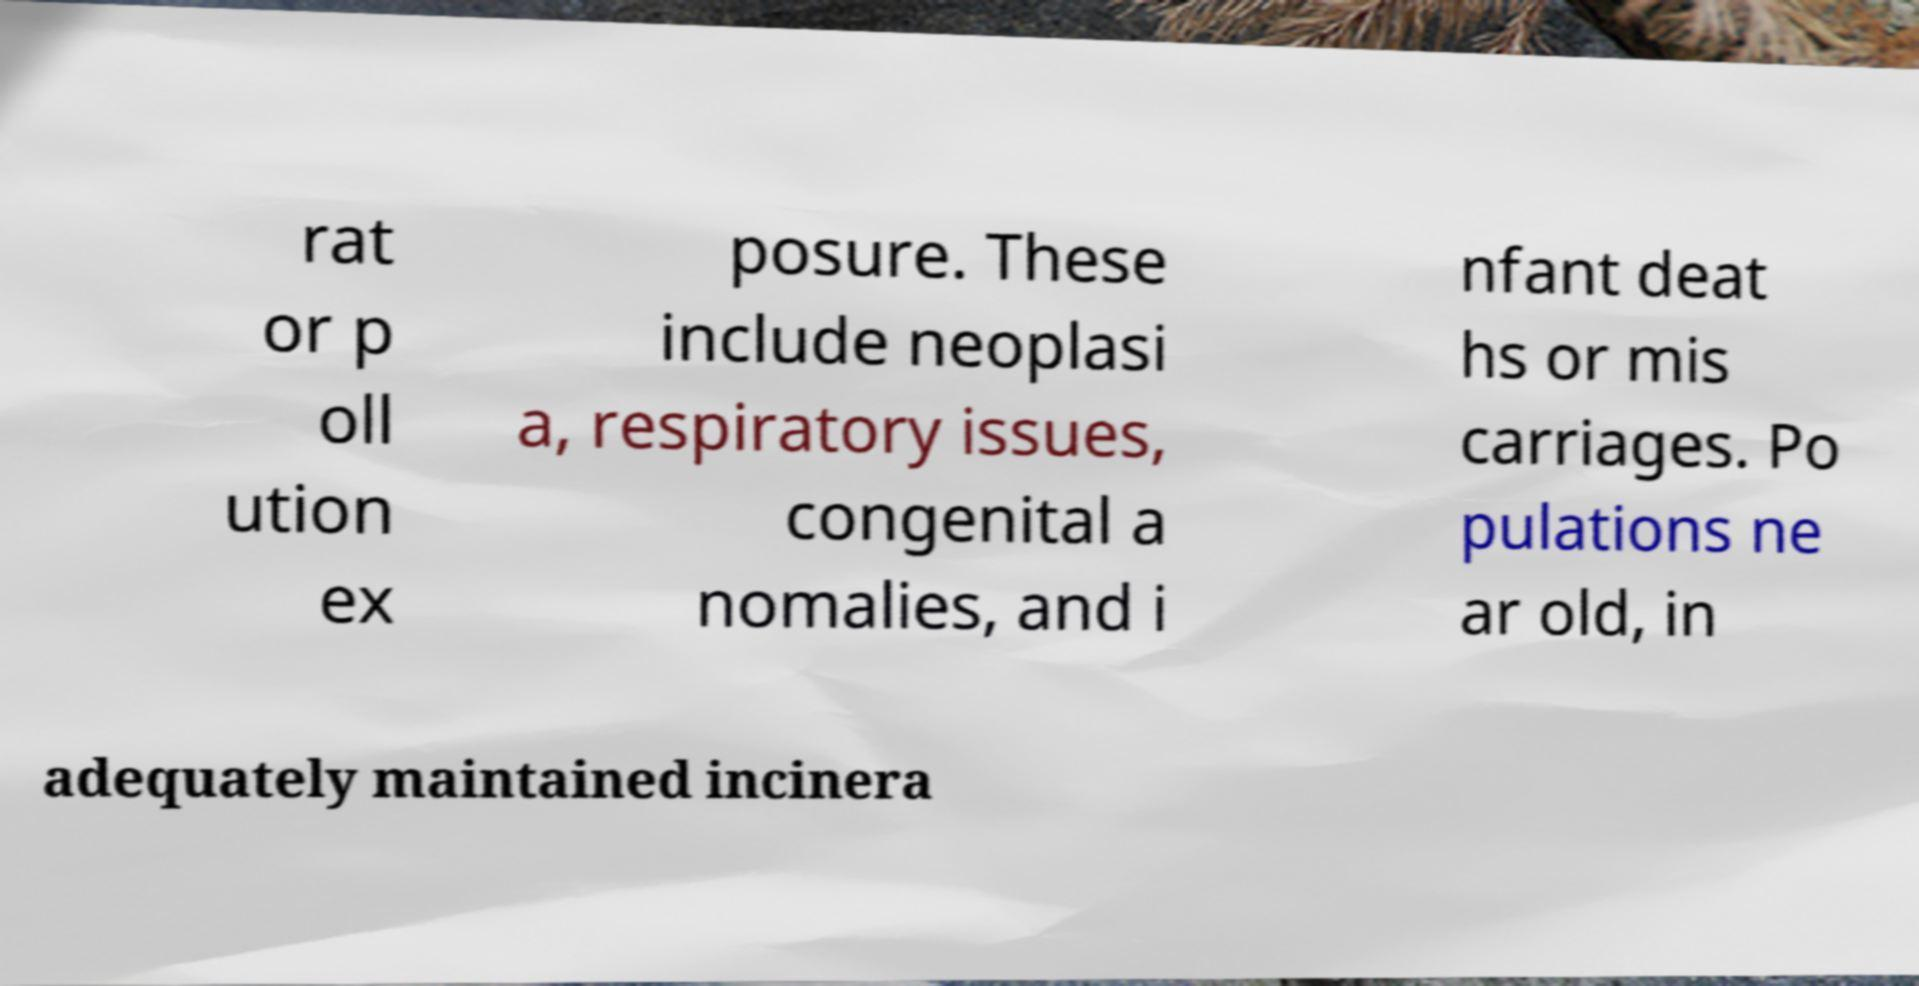There's text embedded in this image that I need extracted. Can you transcribe it verbatim? rat or p oll ution ex posure. These include neoplasi a, respiratory issues, congenital a nomalies, and i nfant deat hs or mis carriages. Po pulations ne ar old, in adequately maintained incinera 